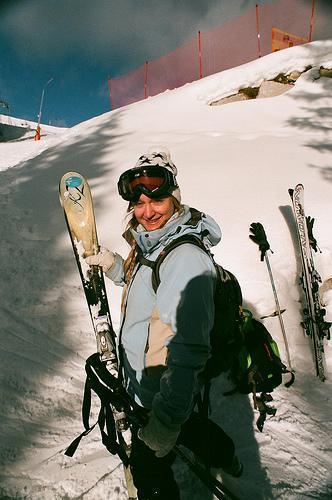How many people in picture?
Give a very brief answer. 1. 